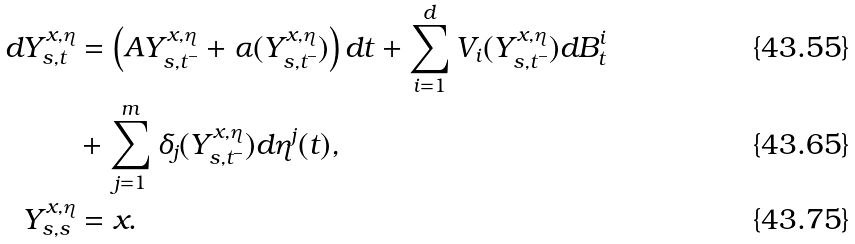Convert formula to latex. <formula><loc_0><loc_0><loc_500><loc_500>d Y _ { s , t } ^ { x , \eta } & = \left ( A Y _ { s , t ^ { - } } ^ { x , \eta } + \alpha ( Y _ { s , t ^ { - } } ^ { x , \eta } ) \right ) d t + \sum _ { i = 1 } ^ { d } V _ { i } ( Y _ { s , t ^ { - } } ^ { x , \eta } ) d B _ { t } ^ { i } \\ & + \sum _ { j = 1 } ^ { m } \delta _ { j } ( Y _ { s , t ^ { - } } ^ { x , \eta } ) d \eta ^ { j } ( t ) , \\ Y _ { s , s } ^ { x , \eta } & = x .</formula> 